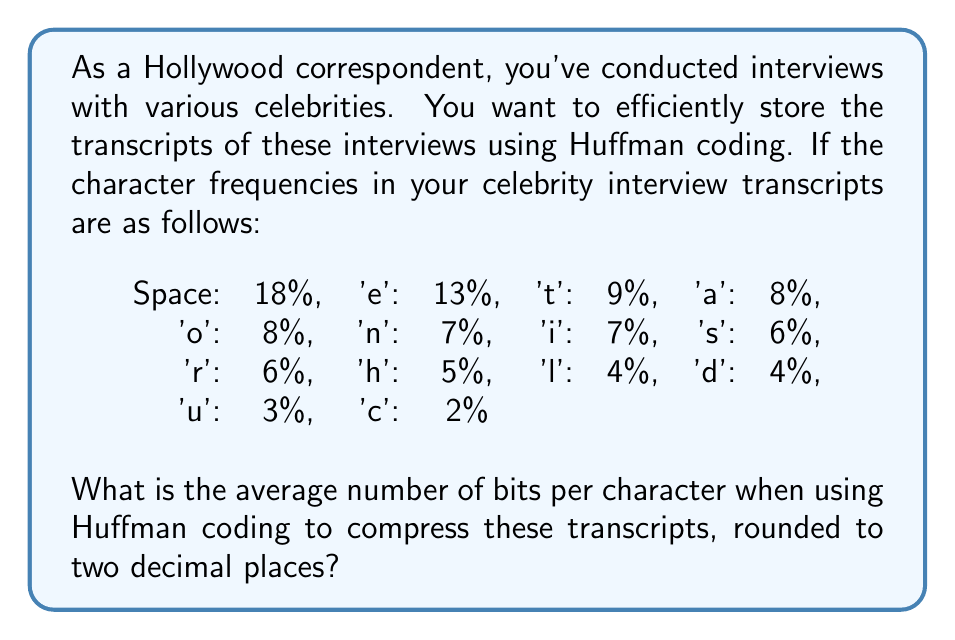Give your solution to this math problem. To solve this problem, we'll follow these steps:

1. Construct the Huffman tree based on the given frequencies.
2. Determine the Huffman code for each character.
3. Calculate the average number of bits per character.

Step 1: Constructing the Huffman tree
We start with the least frequent characters and work our way up:

$$(u,3\%) + (c,2\%) = (uc,5\%)$$
$$(h,5\%) + (uc,5\%) = (huc,10\%)$$
$$(l,4\%) + (d,4\%) = (ld,8\%)$$
$$(r,6\%) + (s,6\%) = (rs,12\%)$$
$$(i,7\%) + (n,7\%) = (in,14\%)$$
$$(a,8\%) + (o,8\%) = (ao,16\%)$$
$$(ld,8\%) + (t,9\%) = (ldt,17\%)$$
$$(huc,10\%) + (e,13\%) = (huce,23\%)$$
$$(rs,12\%) + (in,14\%) = (rsin,26\%)$$
$$(ao,16\%) + (ldt,17\%) = (aoldt,33\%)$$
$$(rsin,26\%) + (huce,23\%) = (rsinhuce,49\%)$$
$$(aoldt,33\%) + (rsinhuce,49\%) = (aoldtrsinhuce,82\%)$$
$$(Space,18\%) + (aoldtrsinhuce,82\%) = (root,100\%)$$

Step 2: Determining Huffman codes
From the tree, we can derive the following Huffman codes:

Space: 0
e: 100
t: 1010
a: 1011
o: 1100
n: 11010
i: 11011
s: 11100
r: 11101
h: 10110
l: 10111
d: 11110
u: 111110
c: 111111

Step 3: Calculating average bits per character
We multiply each character's frequency by its code length and sum:

$$\text{Average} = (18\% \times 1) + (13\% \times 3) + (9\% \times 4) + (8\% \times 4) + (8\% \times 4) + (7\% \times 5) + (7\% \times 5) + (6\% \times 5) + (6\% \times 5) + (5\% \times 5) + (4\% \times 5) + (4\% \times 5) + (3\% \times 6) + (2\% \times 6)$$

$$= 0.18 + 0.39 + 0.36 + 0.32 + 0.32 + 0.35 + 0.35 + 0.30 + 0.30 + 0.25 + 0.20 + 0.20 + 0.18 + 0.12$$

$$= 3.82 \text{ bits per character}$$
Answer: 3.82 bits per character 